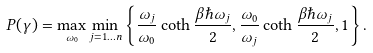Convert formula to latex. <formula><loc_0><loc_0><loc_500><loc_500>P ( \gamma ) = \max _ { \omega _ { 0 } } \min _ { j = 1 \dots n } \left \{ \frac { \omega _ { j } } { \omega _ { 0 } } \coth \frac { \beta \hbar { \omega } _ { j } } { 2 } , \frac { \omega _ { 0 } } { \omega _ { j } } \coth \frac { \beta \hbar { \omega } _ { j } } { 2 } , 1 \right \} .</formula> 